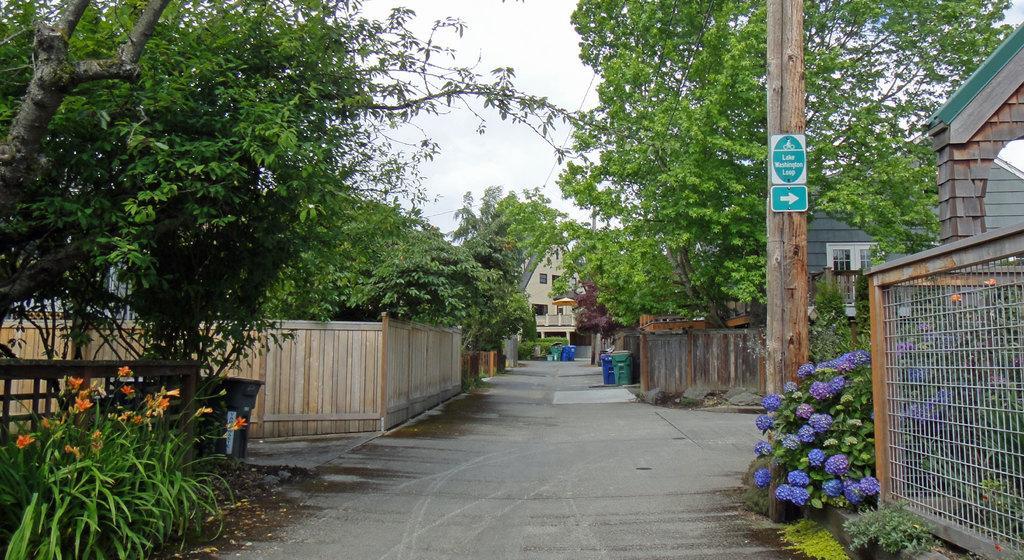In one or two sentences, can you explain what this image depicts? In this image, there are houses, trees, plants, compound walls and I can see the boards attached to a wooden pole. I can see the dustbins on the road. On the right side of the image, there is a fence. In the background there is the sky. 